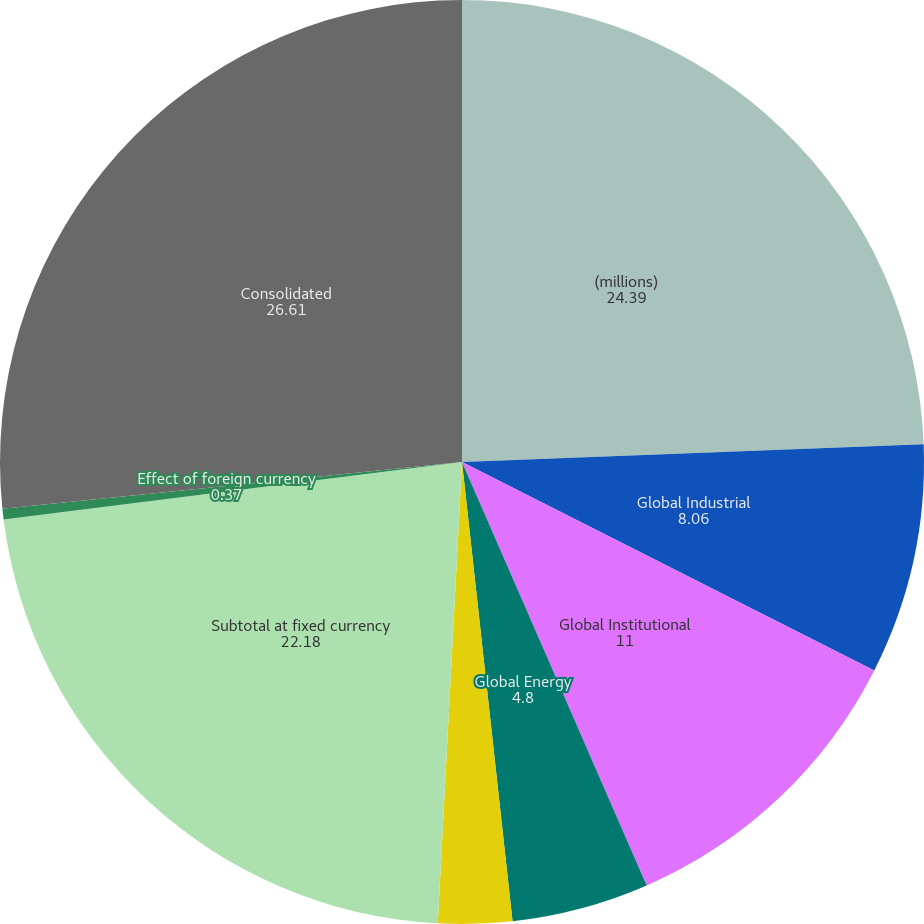Convert chart. <chart><loc_0><loc_0><loc_500><loc_500><pie_chart><fcel>(millions)<fcel>Global Industrial<fcel>Global Institutional<fcel>Global Energy<fcel>Other<fcel>Subtotal at fixed currency<fcel>Effect of foreign currency<fcel>Consolidated<nl><fcel>24.39%<fcel>8.06%<fcel>11.0%<fcel>4.8%<fcel>2.58%<fcel>22.18%<fcel>0.37%<fcel>26.61%<nl></chart> 